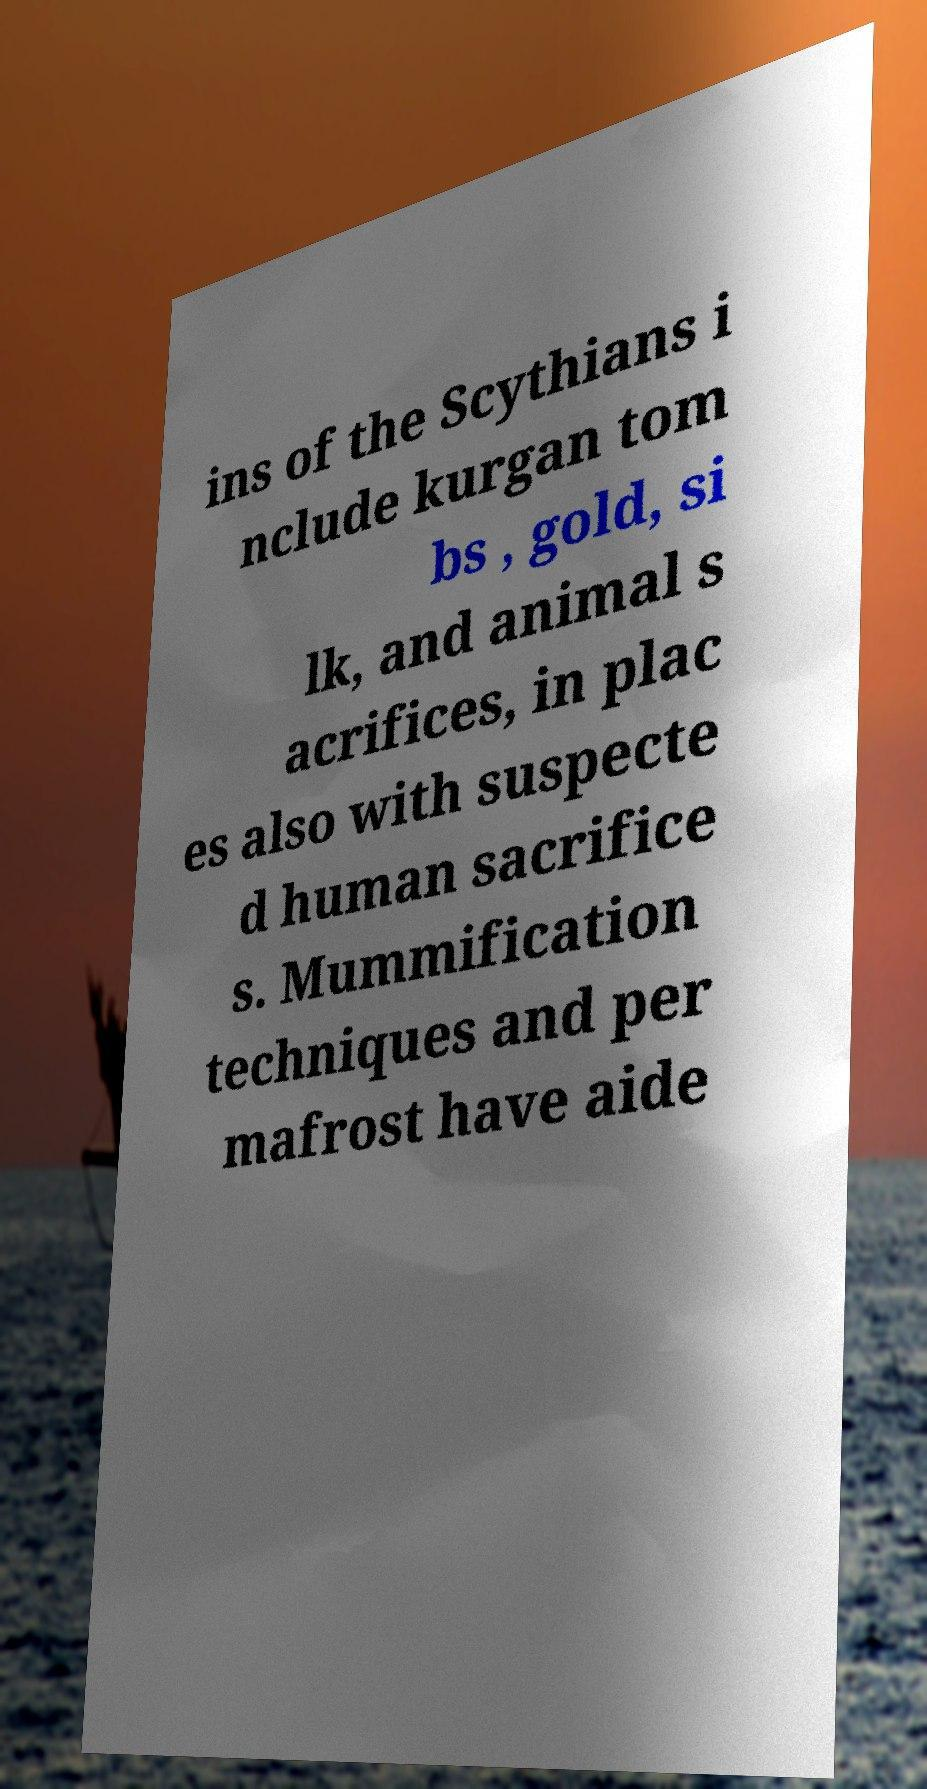Could you extract and type out the text from this image? ins of the Scythians i nclude kurgan tom bs , gold, si lk, and animal s acrifices, in plac es also with suspecte d human sacrifice s. Mummification techniques and per mafrost have aide 